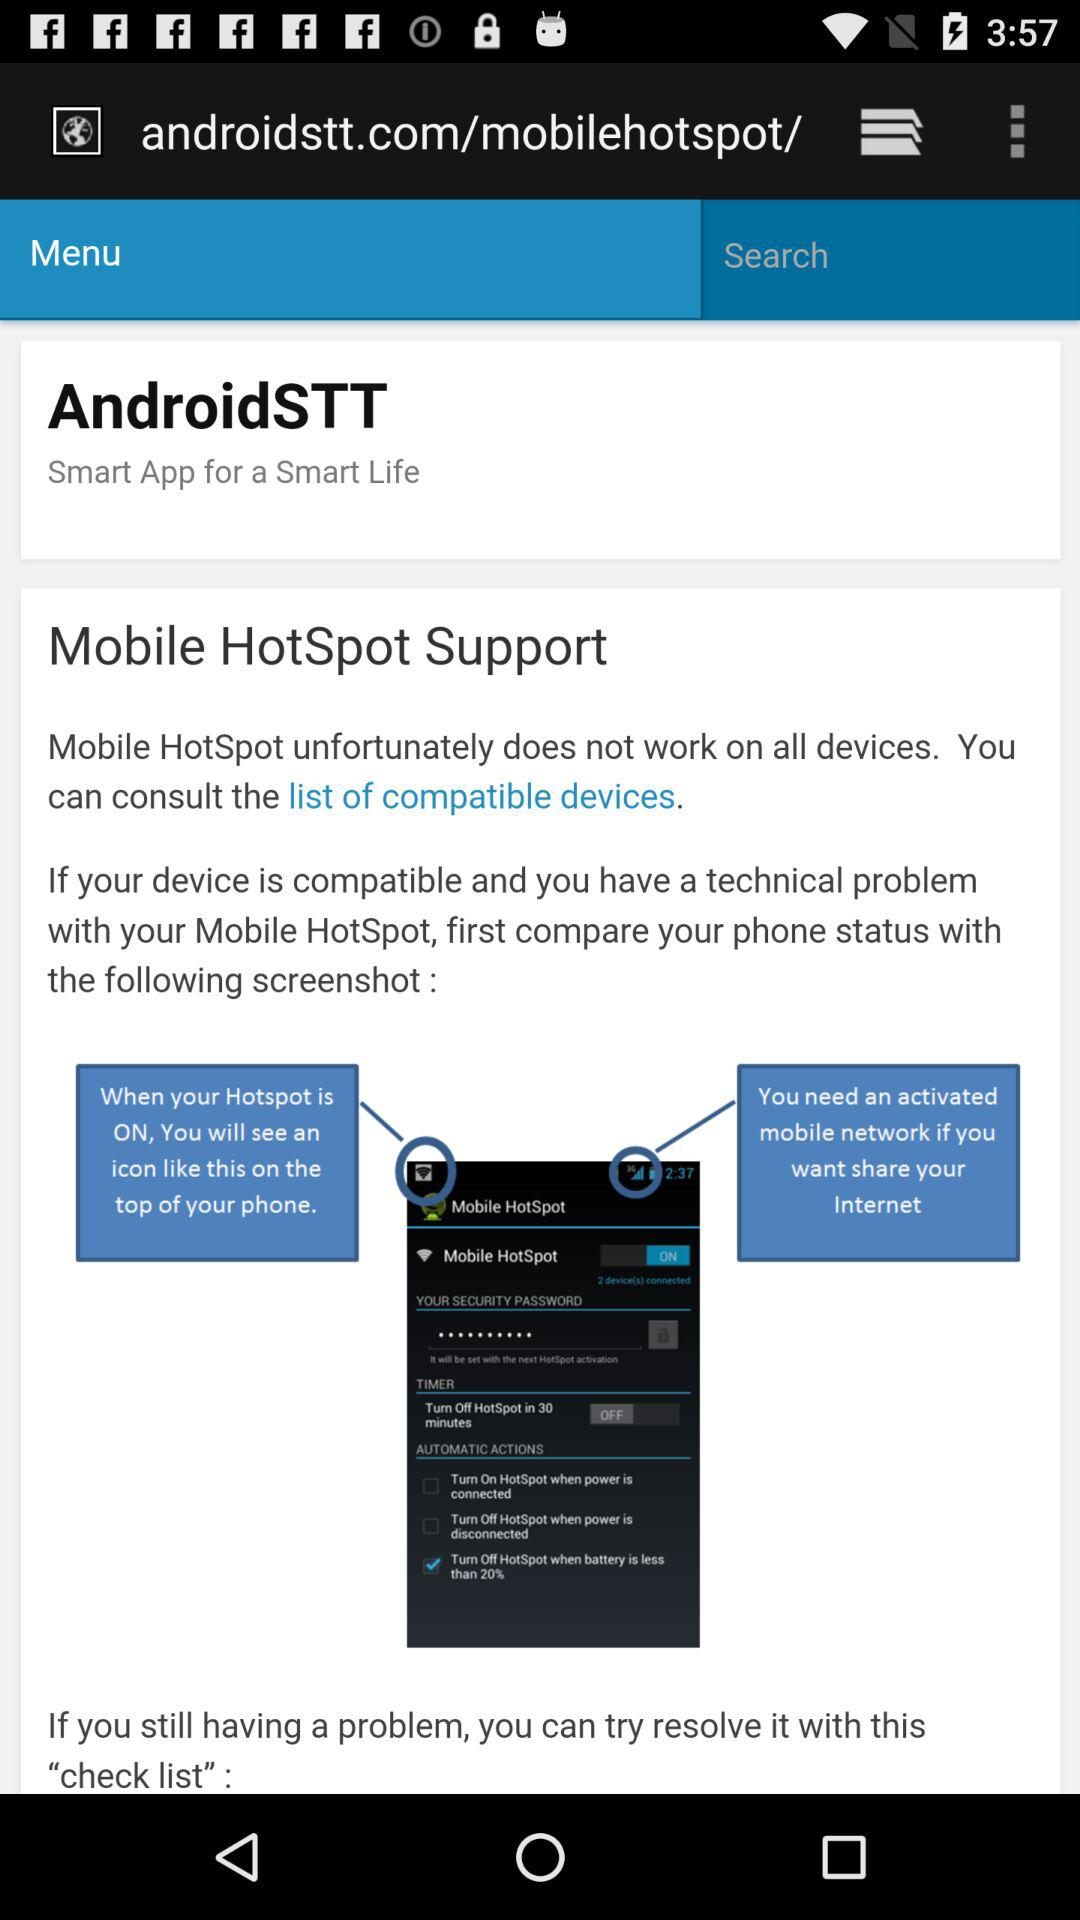What is the other issue faced if the device is compatible while using mobile hotspot?
When the provided information is insufficient, respond with <no answer>. <no answer> 